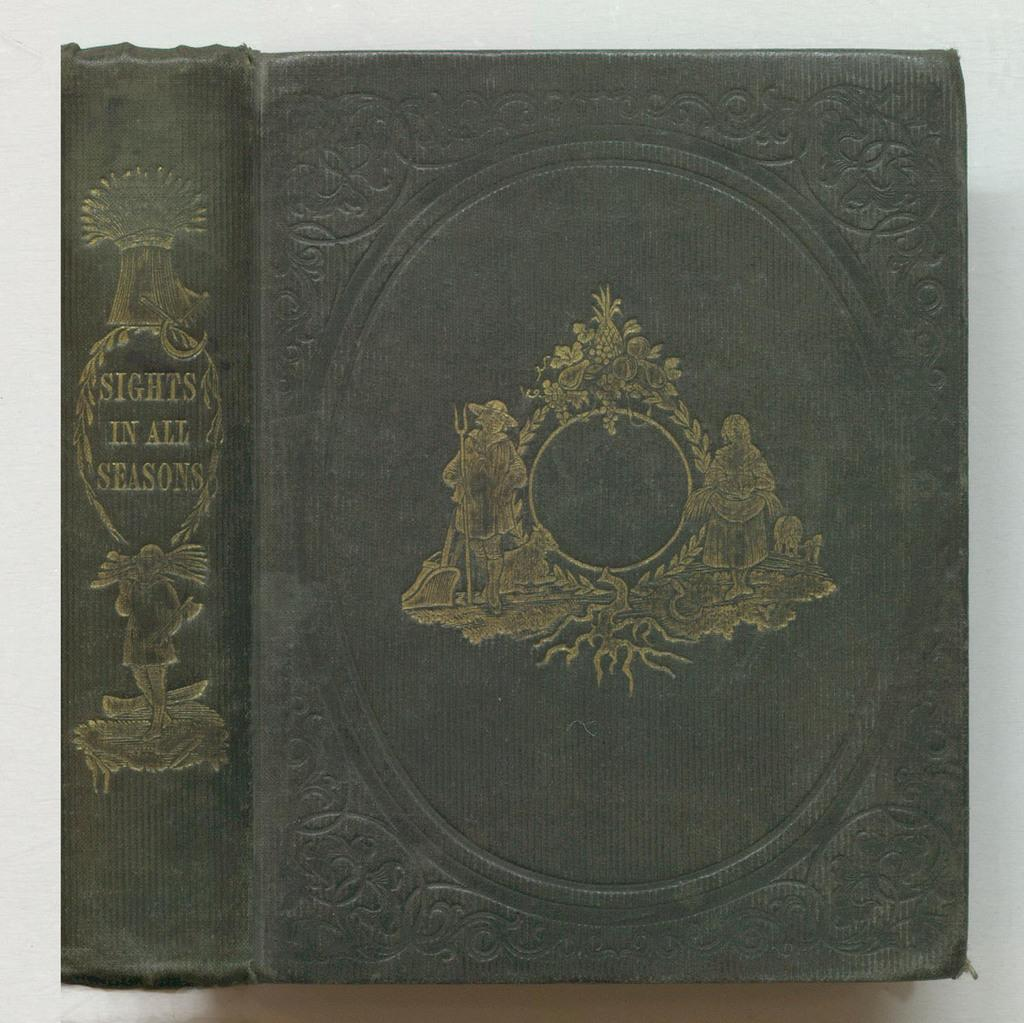<image>
Write a terse but informative summary of the picture. A book titled " Sights in all seasons" that is black. 